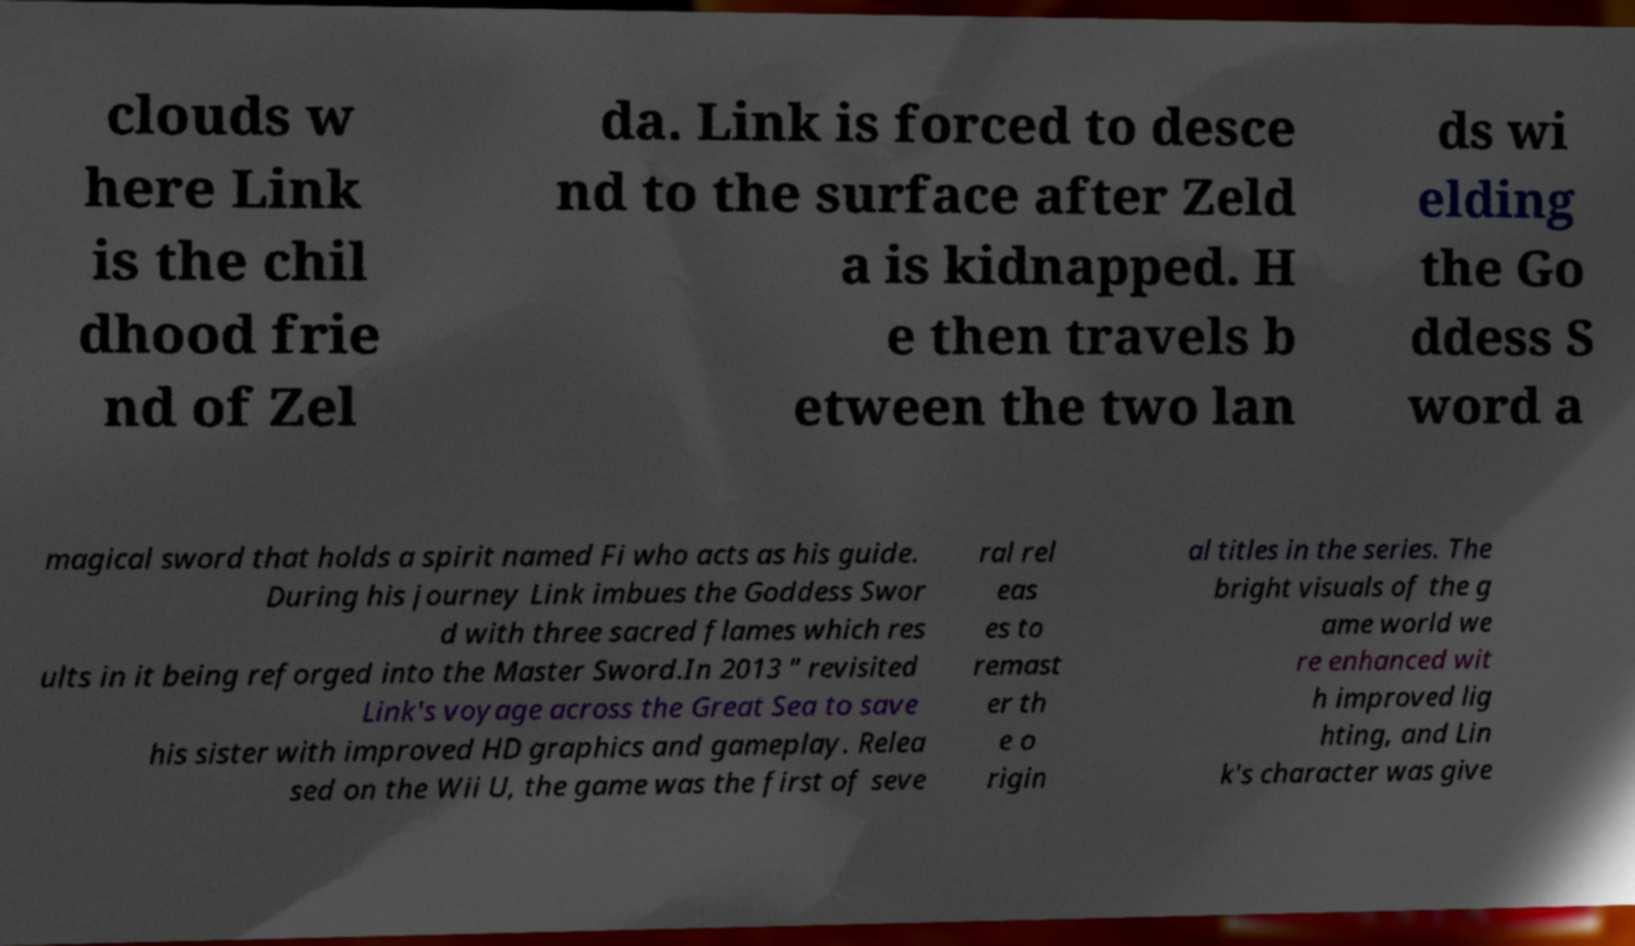There's text embedded in this image that I need extracted. Can you transcribe it verbatim? clouds w here Link is the chil dhood frie nd of Zel da. Link is forced to desce nd to the surface after Zeld a is kidnapped. H e then travels b etween the two lan ds wi elding the Go ddess S word a magical sword that holds a spirit named Fi who acts as his guide. During his journey Link imbues the Goddess Swor d with three sacred flames which res ults in it being reforged into the Master Sword.In 2013 " revisited Link's voyage across the Great Sea to save his sister with improved HD graphics and gameplay. Relea sed on the Wii U, the game was the first of seve ral rel eas es to remast er th e o rigin al titles in the series. The bright visuals of the g ame world we re enhanced wit h improved lig hting, and Lin k's character was give 